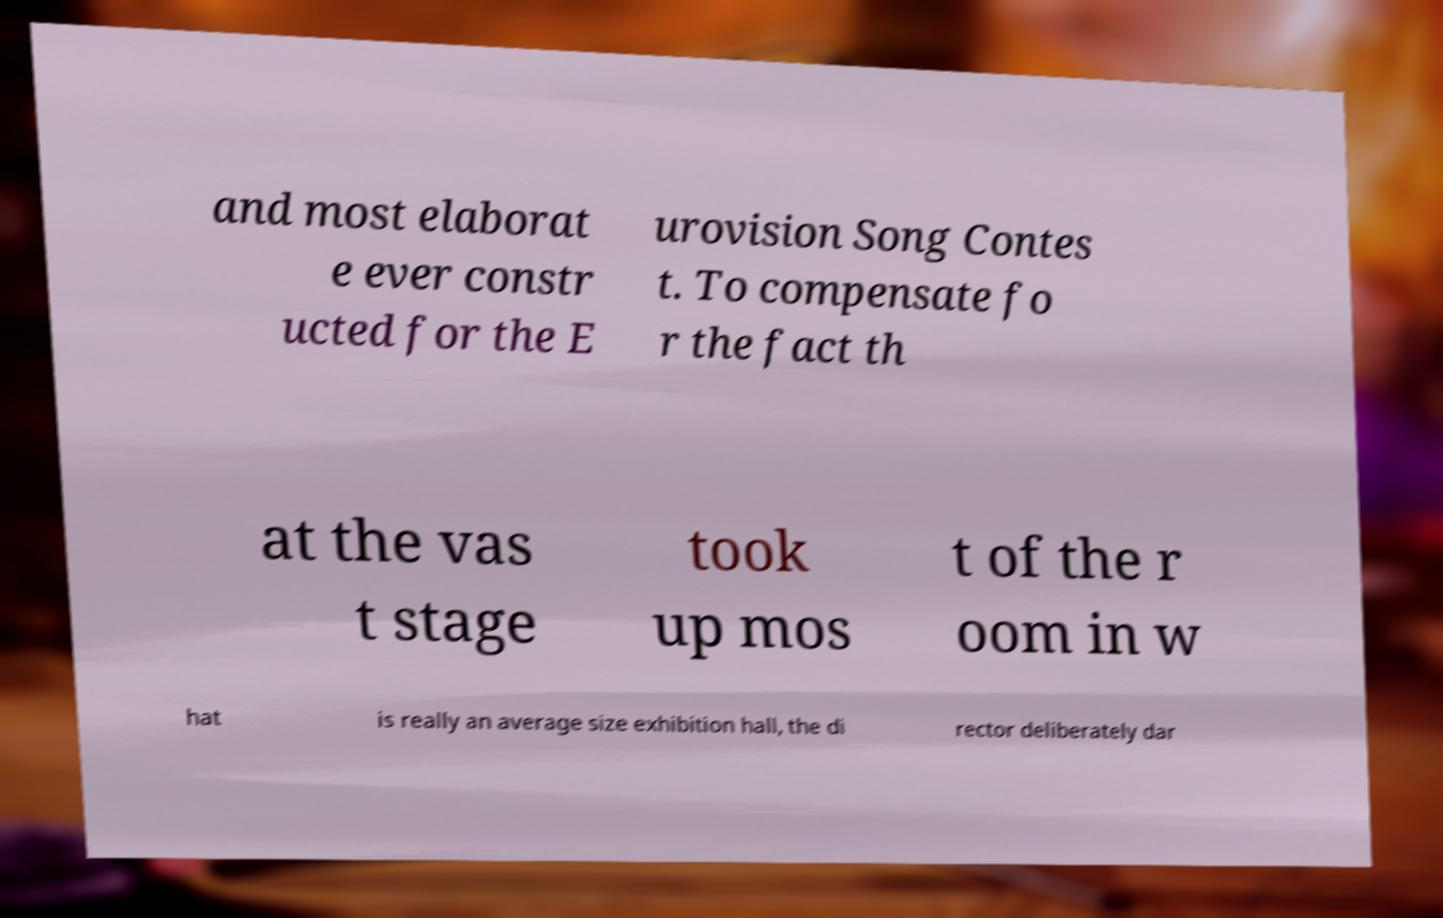Please read and relay the text visible in this image. What does it say? and most elaborat e ever constr ucted for the E urovision Song Contes t. To compensate fo r the fact th at the vas t stage took up mos t of the r oom in w hat is really an average size exhibition hall, the di rector deliberately dar 